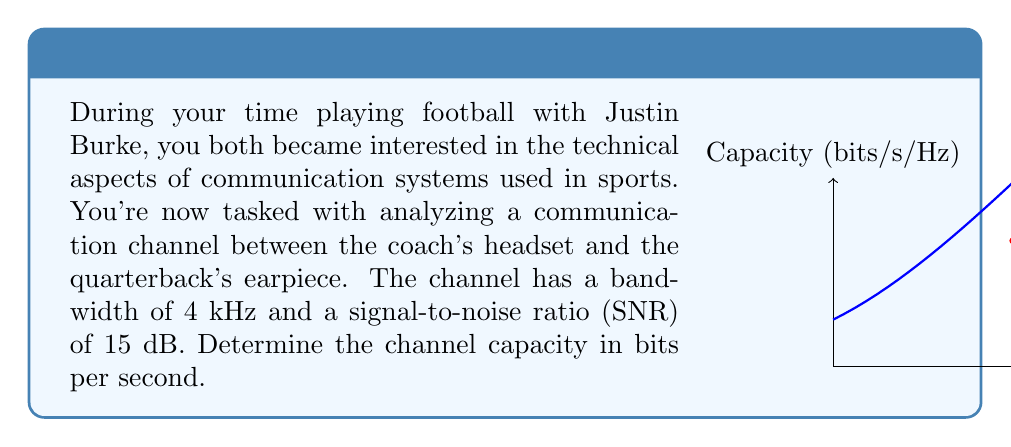Teach me how to tackle this problem. To solve this problem, we'll use the Shannon-Hartley theorem, which gives the channel capacity for a noisy communication channel. The steps are as follows:

1) The Shannon-Hartley theorem states that the channel capacity $C$ is:

   $$C = B \log_2(1 + SNR)$$

   where $B$ is the bandwidth in Hz, and SNR is the signal-to-noise ratio.

2) We're given the bandwidth $B = 4$ kHz = 4000 Hz.

3) The SNR is given in dB, but we need it in linear form. To convert:
   
   $SNR_{linear} = 10^{SNR_{dB}/10} = 10^{15/10} = 10^{1.5} \approx 31.6228$

4) Now we can plug these values into the formula:

   $$C = 4000 \log_2(1 + 31.6228)$$

5) Calculate:
   
   $$C = 4000 \cdot \log_2(32.6228)$$
   $$C = 4000 \cdot 5.0284$$
   $$C = 20,113.6$$

6) Round to the nearest whole number:

   $$C \approx 20,114 \text{ bits per second}$$

The graph in the question visualizes the relationship between SNR and capacity per Hz, with the red dot indicating the operating point for this system.
Answer: 20,114 bits/s 